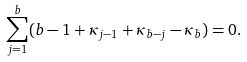Convert formula to latex. <formula><loc_0><loc_0><loc_500><loc_500>\sum _ { j = 1 } ^ { b } ( b - 1 + \kappa _ { j - 1 } + \kappa _ { b - j } - \kappa _ { b } ) = 0 .</formula> 